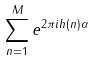Convert formula to latex. <formula><loc_0><loc_0><loc_500><loc_500>\sum _ { n = 1 } ^ { M } e ^ { 2 \pi i h ( n ) \alpha }</formula> 